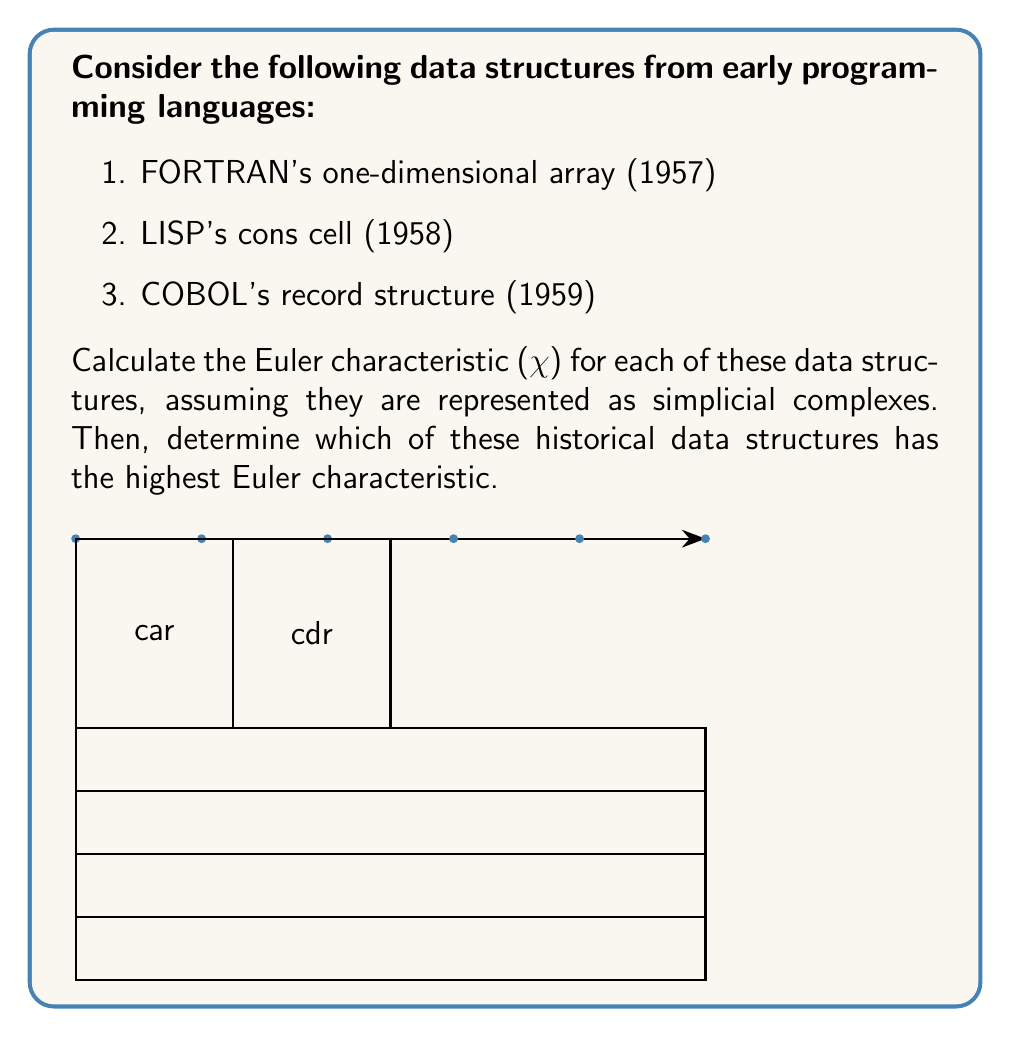Could you help me with this problem? To calculate the Euler characteristic ($\chi$) for each data structure, we need to count the number of vertices (V), edges (E), and faces (F) in their simplicial complex representations. Then, we use the formula:

$$\chi = V - E + F$$

1. FORTRAN's one-dimensional array:
   - Vertices (V): 6 (array elements)
   - Edges (E): 5 (connections between elements)
   - Faces (F): 0 (no enclosed areas)
   
   $$\chi_{FORTRAN} = 6 - 5 + 0 = 1$$

2. LISP's cons cell:
   - Vertices (V): 4 (corners of the cell)
   - Edges (E): 5 (4 outer edges + 1 dividing edge)
   - Faces (F): 2 (left and right sections)
   
   $$\chi_{LISP} = 4 - 5 + 2 = 1$$

3. COBOL's record structure:
   - Vertices (V): 8 (corners of the record)
   - Edges (E): 12 (8 outer edges + 4 dividing lines)
   - Faces (F): 5 (4 sections + 1 outer face)
   
   $$\chi_{COBOL} = 8 - 12 + 5 = 1$$

Comparing the Euler characteristics:
$$\chi_{FORTRAN} = \chi_{LISP} = \chi_{COBOL} = 1$$

All three data structures have the same Euler characteristic of 1.
Answer: $\chi_{FORTRAN} = \chi_{LISP} = \chi_{COBOL} = 1$. All have the highest (equal) Euler characteristic. 